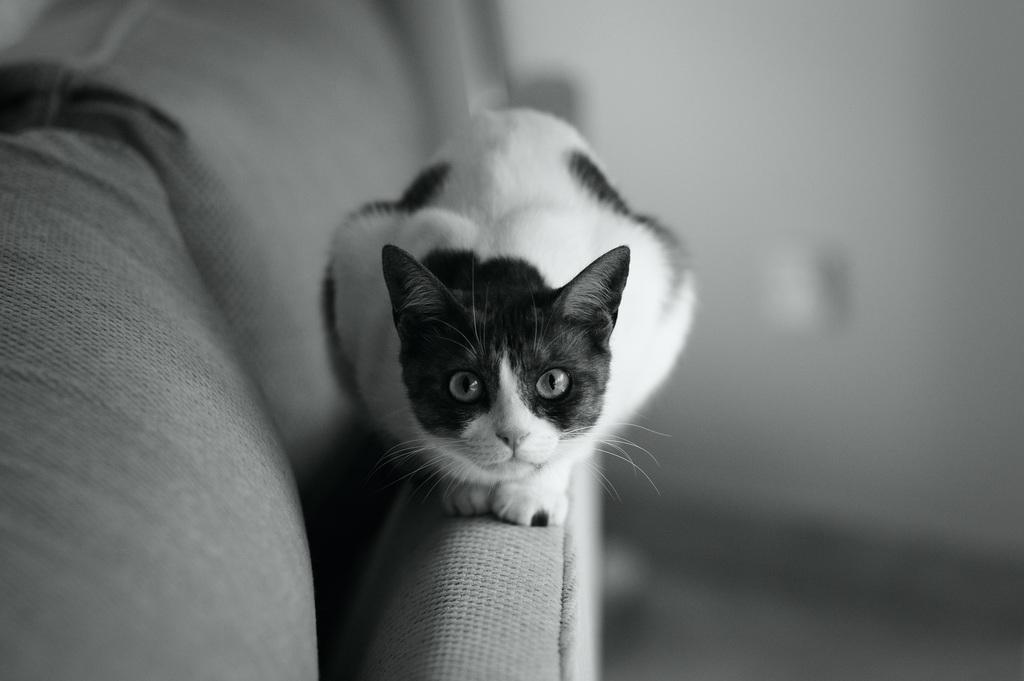What type of animal is in the image? There is a cat in the image. Where is the cat located? The cat is sitting on a sofa. What color scheme is used in the image? The image is in black and white color. What type of fork can be seen in the image? There is no fork present in the image; it features a cat sitting on a sofa. 